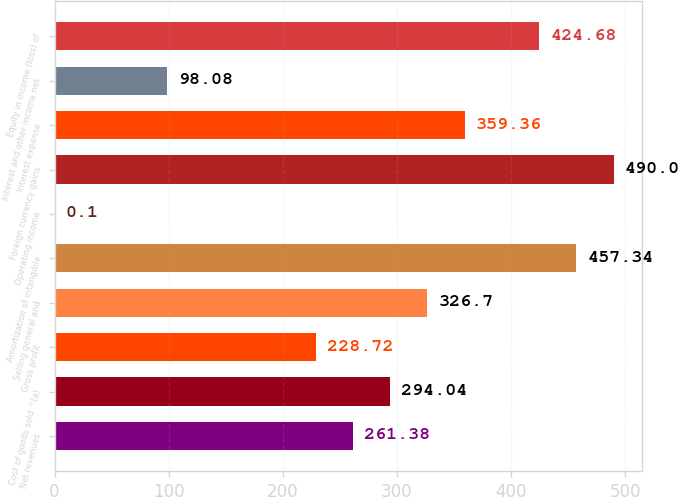<chart> <loc_0><loc_0><loc_500><loc_500><bar_chart><fcel>Net revenues<fcel>Cost of goods sold ^(a)<fcel>Gross profit<fcel>Selling general and<fcel>Amortization of intangible<fcel>Operating income<fcel>Foreign currency gains<fcel>Interest expense<fcel>Interest and other income net<fcel>Equity in income (loss) of<nl><fcel>261.38<fcel>294.04<fcel>228.72<fcel>326.7<fcel>457.34<fcel>0.1<fcel>490<fcel>359.36<fcel>98.08<fcel>424.68<nl></chart> 